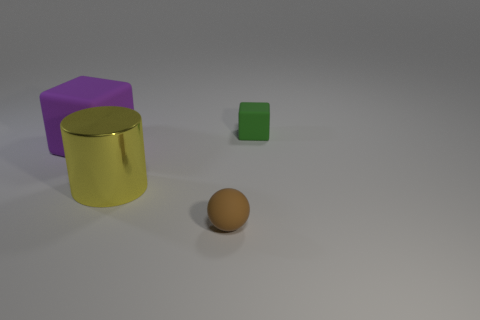How many small matte objects have the same color as the small cube?
Your response must be concise. 0. Does the shiny cylinder have the same color as the matte block on the right side of the large purple thing?
Give a very brief answer. No. The rubber object that is both left of the green thing and behind the rubber sphere has what shape?
Make the answer very short. Cube. The brown thing that is on the right side of the large thing that is on the right side of the block left of the brown object is made of what material?
Give a very brief answer. Rubber. Are there more tiny brown balls that are left of the purple object than brown matte spheres that are behind the small matte block?
Your answer should be compact. No. How many yellow things are made of the same material as the brown thing?
Your answer should be compact. 0. There is a matte thing behind the purple thing; is it the same shape as the rubber object that is to the left of the brown matte thing?
Ensure brevity in your answer.  Yes. There is a matte thing behind the large purple object; what color is it?
Your response must be concise. Green. Are there any small green objects of the same shape as the tiny brown object?
Ensure brevity in your answer.  No. What is the small brown object made of?
Ensure brevity in your answer.  Rubber. 